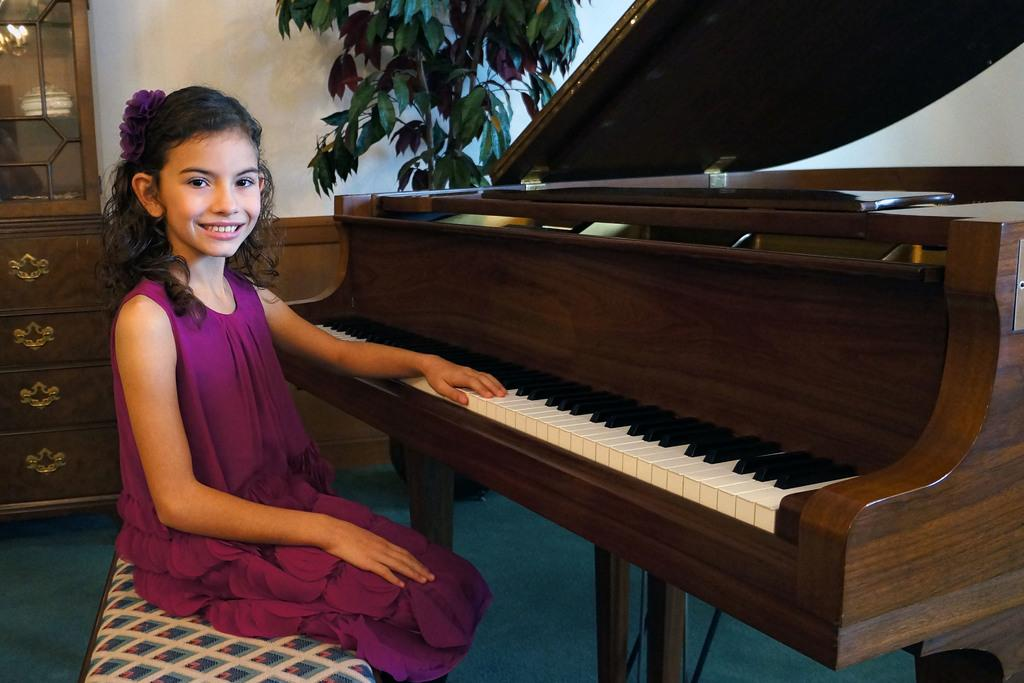Who is the main subject in the image? There is a girl in the image. What is the girl doing in the image? The girl is sitting in a chair and playing a piano. What can be seen in the background of the image? There is a cupboard and a plant in the background of the image. What arithmetic problem is the girl trying to solve in the image? There is no indication in the image that the girl is trying to solve an arithmetic problem. Can you describe the stranger in the image? There is no stranger present in the image; it only features the girl playing the piano. 